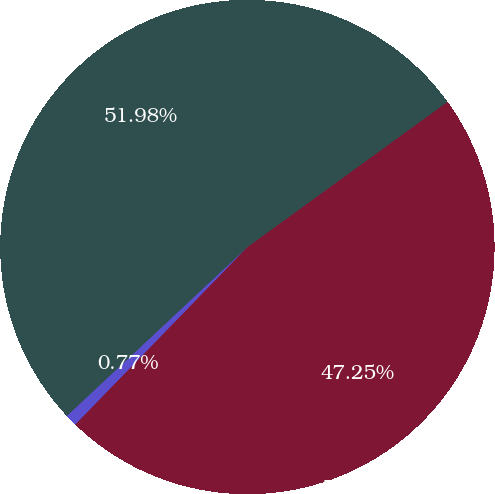Convert chart. <chart><loc_0><loc_0><loc_500><loc_500><pie_chart><fcel>Basic weighted average shares<fcel>Weighted average dilutive<fcel>Diluted weighted average<nl><fcel>47.25%<fcel>0.77%<fcel>51.98%<nl></chart> 